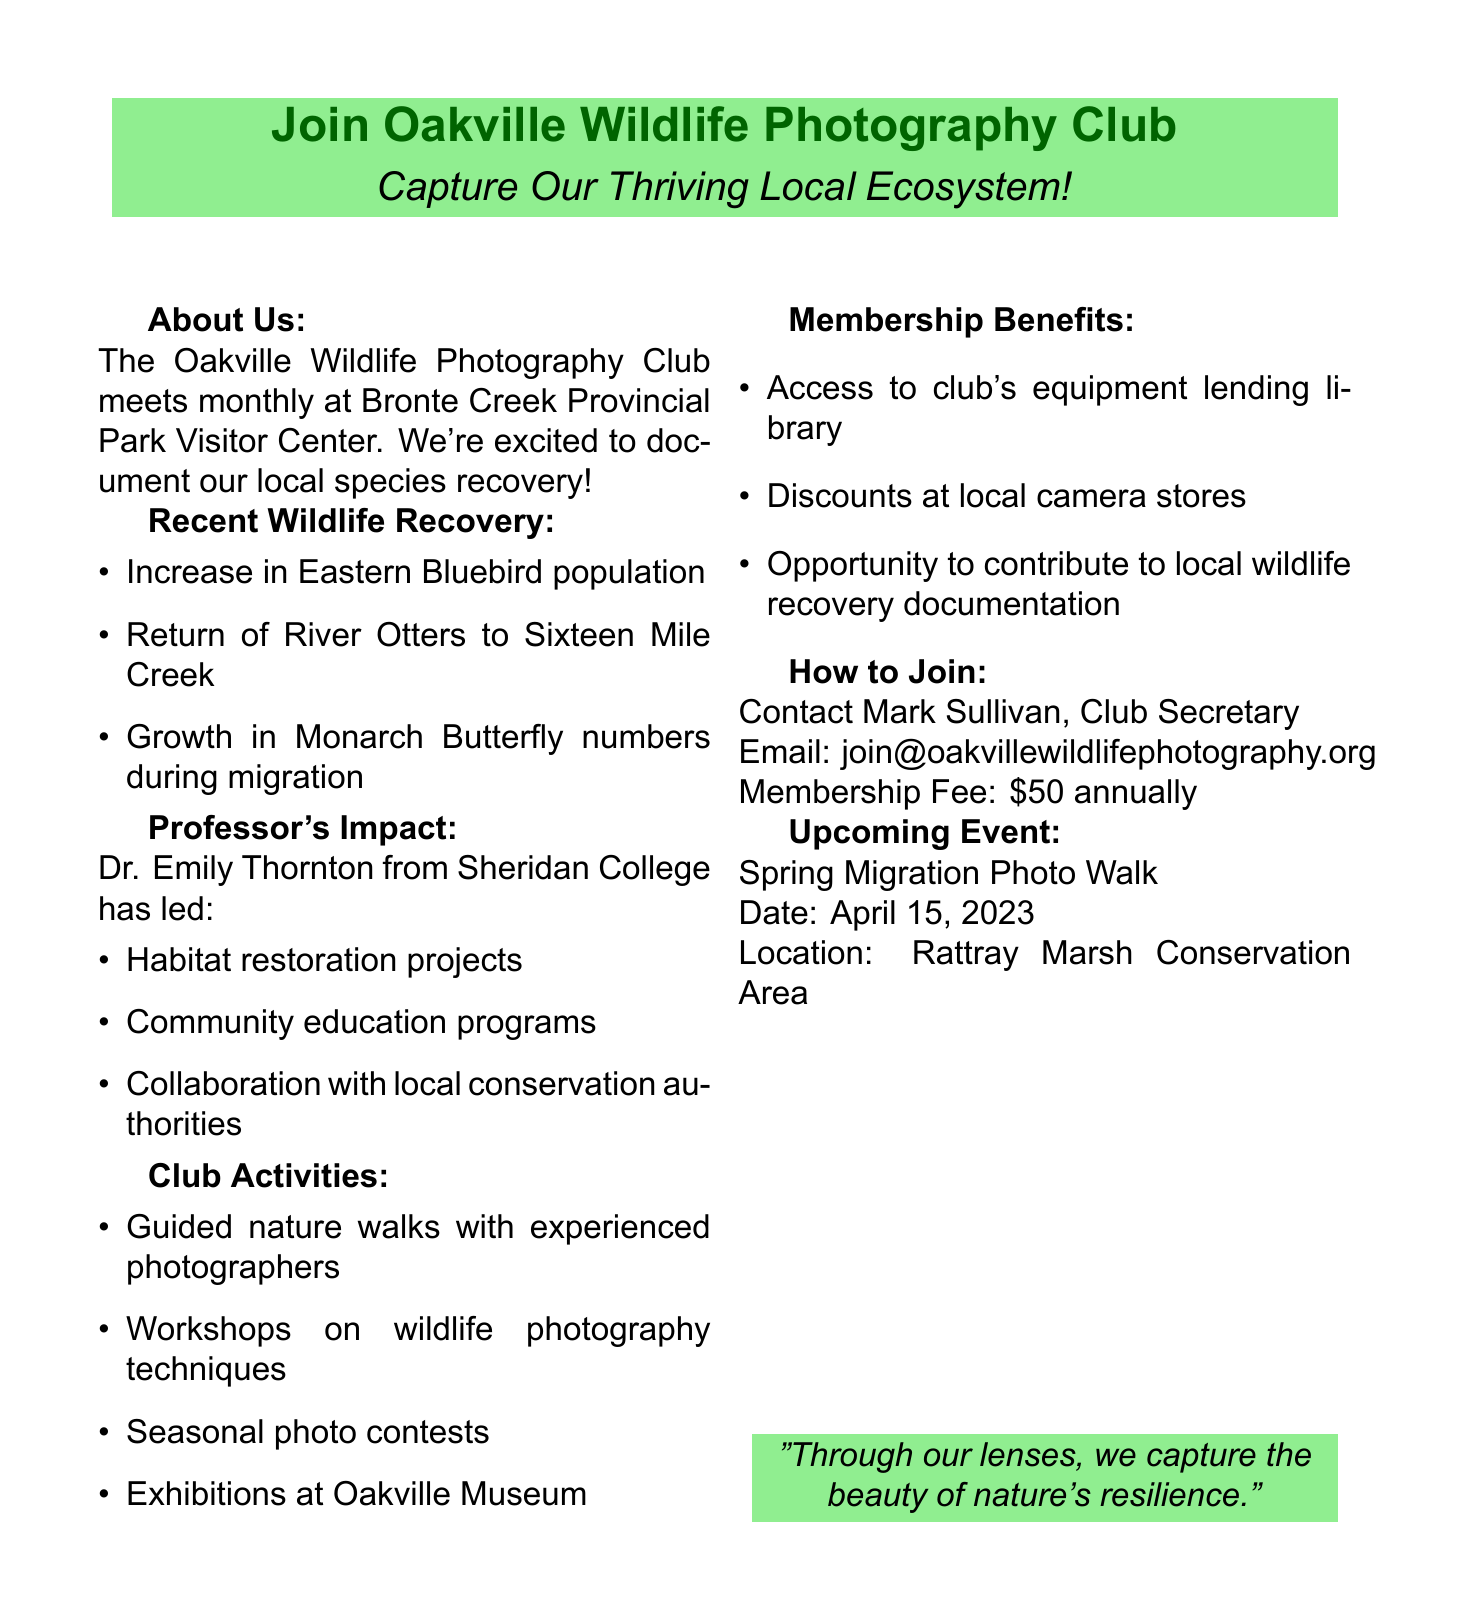What is the name of the club? The club's name is located in the introduction section of the document.
Answer: Oakville Wildlife Photography Club How often does the club meet? The frequency of meetings is mentioned in the introduction.
Answer: Monthly What recent wildlife recovery was noted in the document? The document lists several examples of wildlife recovery in a specific section.
Answer: Increase in Eastern Bluebird population Who is the professor associated with the club? The name of the professor is found in the professor impact section.
Answer: Dr. Emily Thornton What is the membership fee for the club? The document specifies the annual membership fee in the "How to Join" section.
Answer: $50 annually What type of upcoming event is mentioned? The upcoming event details are found in the document, indicating its nature.
Answer: Spring Migration Photo Walk What is one of the benefits of club membership? The membership benefits are listed in a specific section of the document.
Answer: Access to club's equipment lending library Where does the club meet? The meeting location is provided in the introduction of the document.
Answer: Bronte Creek Provincial Park Visitor Center What date is the Spring Migration Photo Walk scheduled for? The document provides the date of the upcoming event in a specific format.
Answer: April 15, 2023 